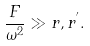Convert formula to latex. <formula><loc_0><loc_0><loc_500><loc_500>\frac { F } { \omega ^ { 2 } } \gg r , r ^ { ^ { \prime } } .</formula> 